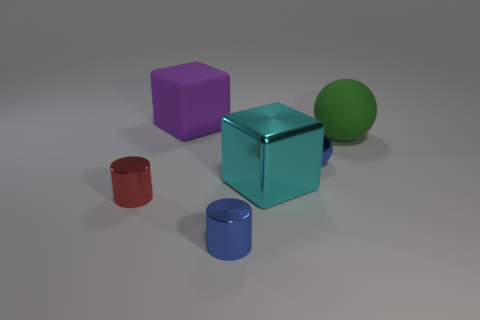Are there an equal number of big purple rubber blocks that are to the right of the green thing and tiny blue balls?
Offer a very short reply. No. What number of objects are either large brown cubes or large purple blocks?
Your answer should be compact. 1. There is a small metal thing that is on the left side of the big thing that is behind the green rubber object; what shape is it?
Your answer should be very brief. Cylinder. There is a big object that is the same material as the small red cylinder; what shape is it?
Your answer should be compact. Cube. There is a metal cylinder that is to the right of the block that is behind the cyan thing; what is its size?
Your response must be concise. Small. What is the shape of the large green object?
Give a very brief answer. Sphere. How many large objects are shiny cubes or gray cylinders?
Your answer should be compact. 1. The cyan thing that is the same shape as the big purple rubber thing is what size?
Give a very brief answer. Large. What number of blue things are both behind the shiny cube and in front of the small blue sphere?
Keep it short and to the point. 0. Do the large shiny object and the rubber object right of the big matte cube have the same shape?
Your response must be concise. No. 